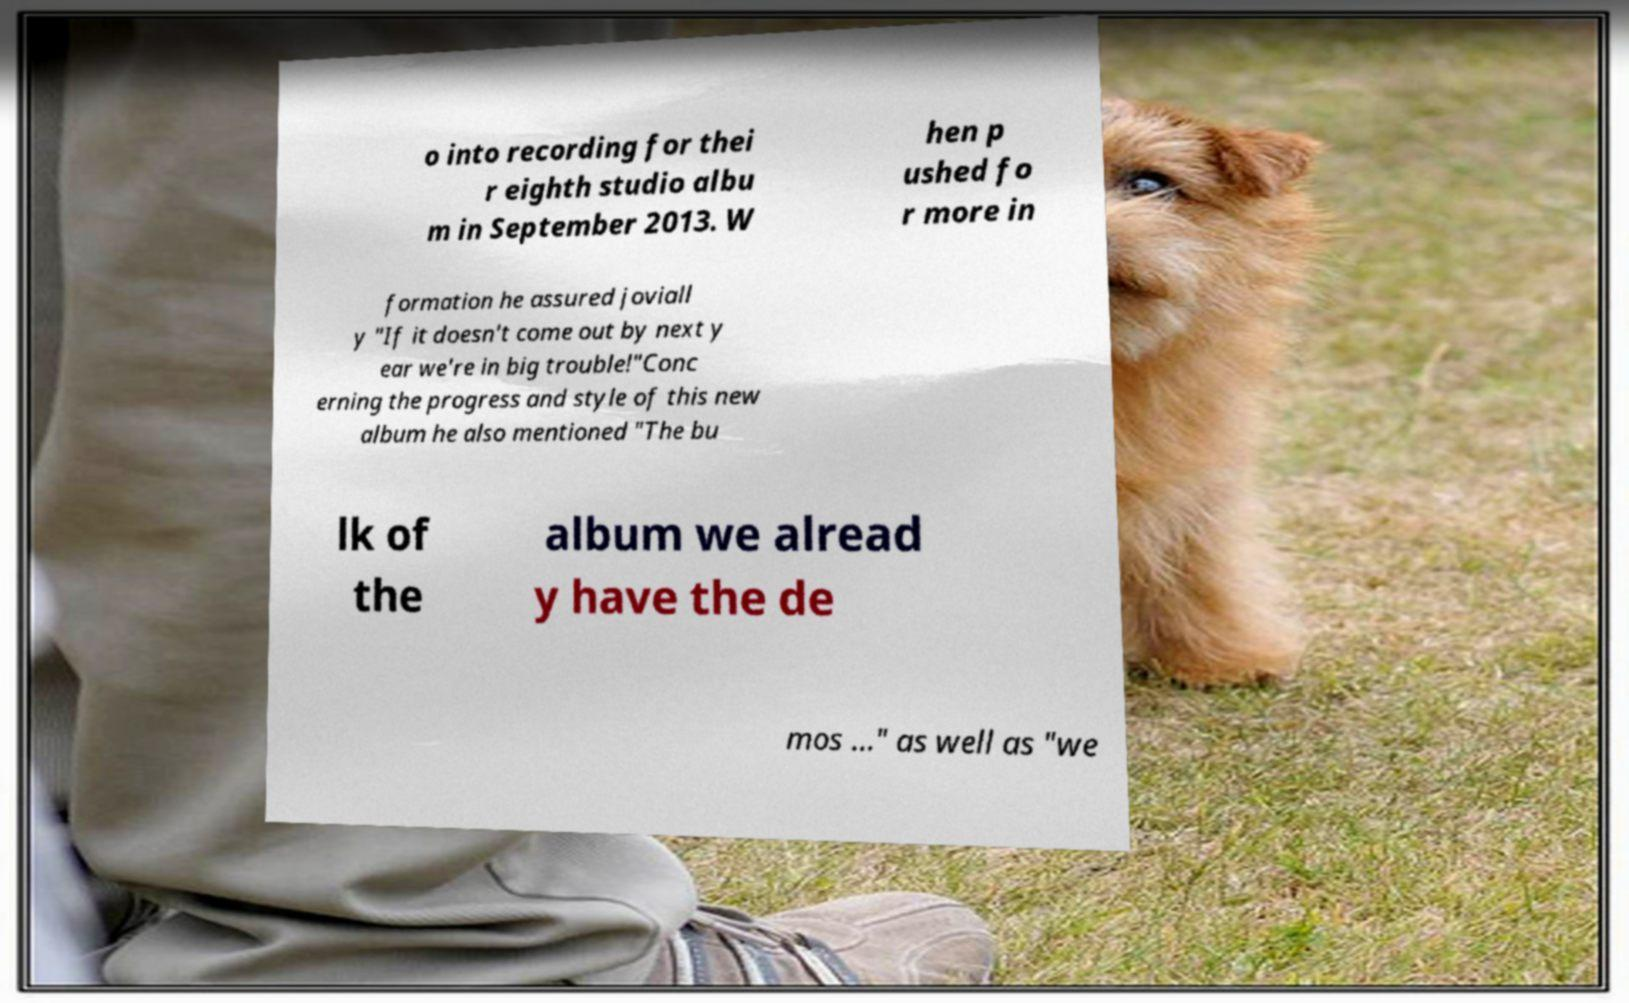There's text embedded in this image that I need extracted. Can you transcribe it verbatim? o into recording for thei r eighth studio albu m in September 2013. W hen p ushed fo r more in formation he assured joviall y "If it doesn't come out by next y ear we're in big trouble!"Conc erning the progress and style of this new album he also mentioned "The bu lk of the album we alread y have the de mos ..." as well as "we 